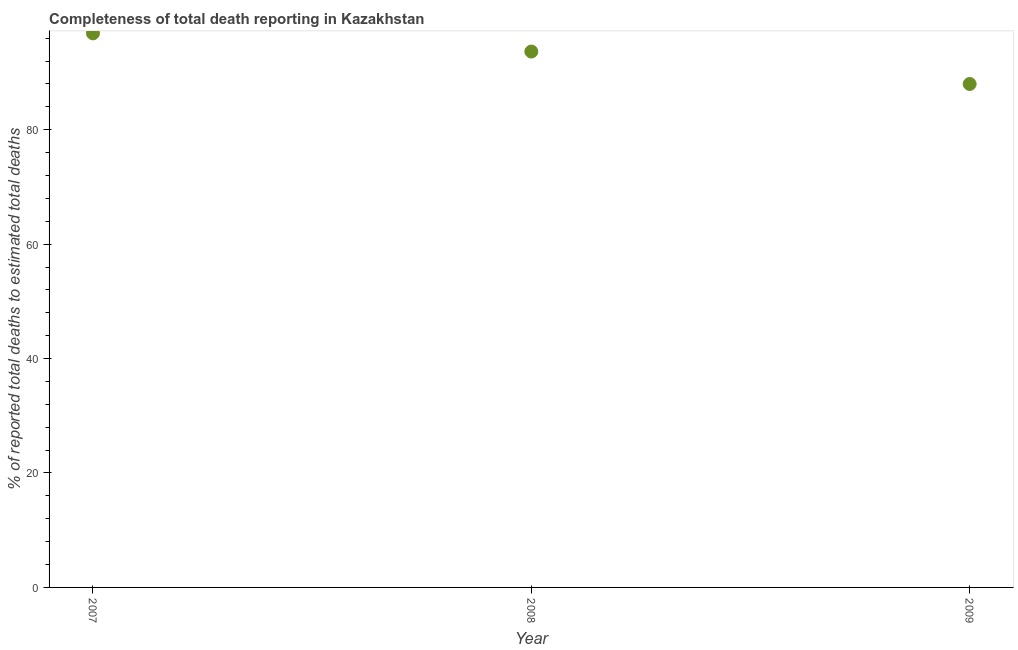What is the completeness of total death reports in 2008?
Give a very brief answer. 93.66. Across all years, what is the maximum completeness of total death reports?
Give a very brief answer. 96.83. Across all years, what is the minimum completeness of total death reports?
Your response must be concise. 87.99. In which year was the completeness of total death reports maximum?
Give a very brief answer. 2007. What is the sum of the completeness of total death reports?
Ensure brevity in your answer.  278.48. What is the difference between the completeness of total death reports in 2008 and 2009?
Your answer should be very brief. 5.67. What is the average completeness of total death reports per year?
Make the answer very short. 92.83. What is the median completeness of total death reports?
Your response must be concise. 93.66. In how many years, is the completeness of total death reports greater than 80 %?
Keep it short and to the point. 3. What is the ratio of the completeness of total death reports in 2007 to that in 2008?
Offer a very short reply. 1.03. Is the completeness of total death reports in 2007 less than that in 2008?
Your answer should be compact. No. What is the difference between the highest and the second highest completeness of total death reports?
Offer a terse response. 3.18. What is the difference between the highest and the lowest completeness of total death reports?
Provide a succinct answer. 8.85. In how many years, is the completeness of total death reports greater than the average completeness of total death reports taken over all years?
Your answer should be compact. 2. How many dotlines are there?
Your response must be concise. 1. Does the graph contain any zero values?
Offer a very short reply. No. What is the title of the graph?
Provide a succinct answer. Completeness of total death reporting in Kazakhstan. What is the label or title of the X-axis?
Give a very brief answer. Year. What is the label or title of the Y-axis?
Keep it short and to the point. % of reported total deaths to estimated total deaths. What is the % of reported total deaths to estimated total deaths in 2007?
Offer a terse response. 96.83. What is the % of reported total deaths to estimated total deaths in 2008?
Provide a succinct answer. 93.66. What is the % of reported total deaths to estimated total deaths in 2009?
Your answer should be very brief. 87.99. What is the difference between the % of reported total deaths to estimated total deaths in 2007 and 2008?
Your answer should be compact. 3.18. What is the difference between the % of reported total deaths to estimated total deaths in 2007 and 2009?
Offer a very short reply. 8.85. What is the difference between the % of reported total deaths to estimated total deaths in 2008 and 2009?
Provide a short and direct response. 5.67. What is the ratio of the % of reported total deaths to estimated total deaths in 2007 to that in 2008?
Offer a very short reply. 1.03. What is the ratio of the % of reported total deaths to estimated total deaths in 2007 to that in 2009?
Your response must be concise. 1.1. What is the ratio of the % of reported total deaths to estimated total deaths in 2008 to that in 2009?
Your response must be concise. 1.06. 